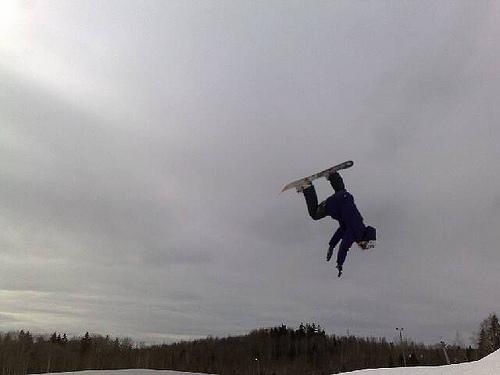Is the sun shining?
Answer briefly. No. Is this man on the snowboard riding on snow?
Quick response, please. No. Is this person upside down?
Answer briefly. Yes. What is the guy doing?
Give a very brief answer. Snowboarding. What is this person riding?
Give a very brief answer. Snowboard. Is this a man or woman flying?
Write a very short answer. Man. Is he upside down?
Be succinct. Yes. What season might it be in the photo?
Be succinct. Winter. What color is the man's shirt?
Short answer required. Black. What sport is being played?
Answer briefly. Snowboarding. Do you think this person will land properly?
Quick response, please. Yes. Are both his feet on the ground?
Answer briefly. No. Is it winter?
Keep it brief. Yes. Will the man get hurt?
Answer briefly. Yes. What are the black clothes for?
Give a very brief answer. Snowboarding. 